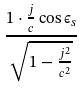Convert formula to latex. <formula><loc_0><loc_0><loc_500><loc_500>\frac { 1 \cdot \frac { j } { c } \cos \epsilon _ { s } } { \sqrt { 1 - \frac { j ^ { 2 } } { c ^ { 2 } } } }</formula> 